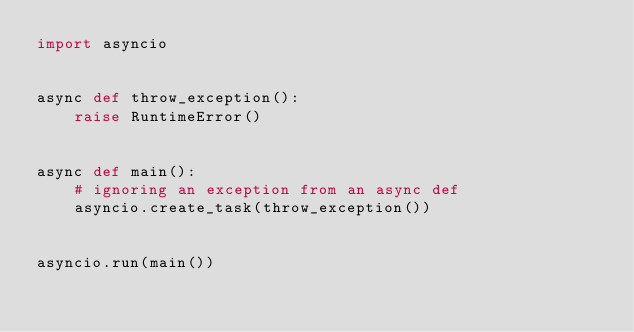<code> <loc_0><loc_0><loc_500><loc_500><_Python_>import asyncio


async def throw_exception():
    raise RuntimeError()


async def main():
    # ignoring an exception from an async def
    asyncio.create_task(throw_exception())


asyncio.run(main())
</code> 